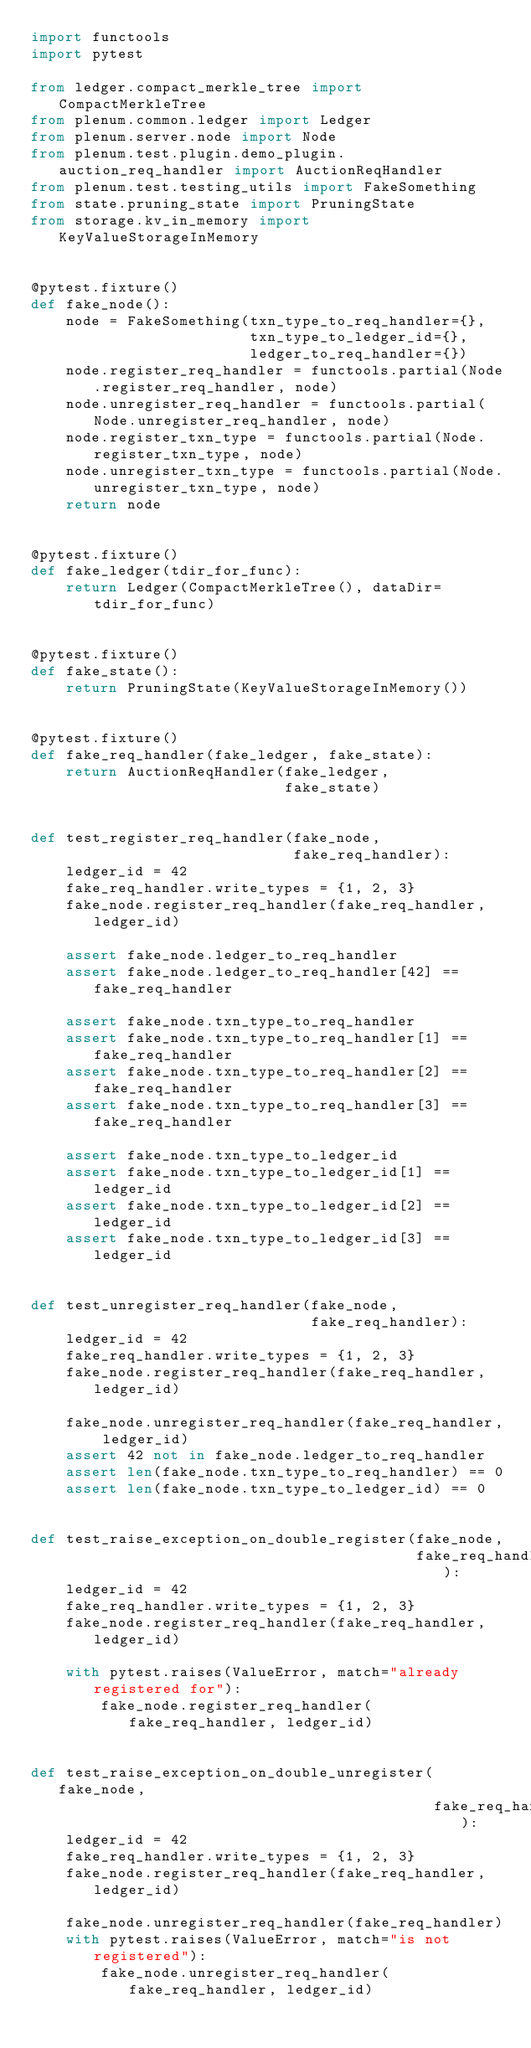Convert code to text. <code><loc_0><loc_0><loc_500><loc_500><_Python_>import functools
import pytest

from ledger.compact_merkle_tree import CompactMerkleTree
from plenum.common.ledger import Ledger
from plenum.server.node import Node
from plenum.test.plugin.demo_plugin.auction_req_handler import AuctionReqHandler
from plenum.test.testing_utils import FakeSomething
from state.pruning_state import PruningState
from storage.kv_in_memory import KeyValueStorageInMemory


@pytest.fixture()
def fake_node():
    node = FakeSomething(txn_type_to_req_handler={},
                         txn_type_to_ledger_id={},
                         ledger_to_req_handler={})
    node.register_req_handler = functools.partial(Node.register_req_handler, node)
    node.unregister_req_handler = functools.partial(Node.unregister_req_handler, node)
    node.register_txn_type = functools.partial(Node.register_txn_type, node)
    node.unregister_txn_type = functools.partial(Node.unregister_txn_type, node)
    return node


@pytest.fixture()
def fake_ledger(tdir_for_func):
    return Ledger(CompactMerkleTree(), dataDir=tdir_for_func)


@pytest.fixture()
def fake_state():
    return PruningState(KeyValueStorageInMemory())


@pytest.fixture()
def fake_req_handler(fake_ledger, fake_state):
    return AuctionReqHandler(fake_ledger,
                             fake_state)


def test_register_req_handler(fake_node,
                              fake_req_handler):
    ledger_id = 42
    fake_req_handler.write_types = {1, 2, 3}
    fake_node.register_req_handler(fake_req_handler, ledger_id)

    assert fake_node.ledger_to_req_handler
    assert fake_node.ledger_to_req_handler[42] == fake_req_handler

    assert fake_node.txn_type_to_req_handler
    assert fake_node.txn_type_to_req_handler[1] == fake_req_handler
    assert fake_node.txn_type_to_req_handler[2] == fake_req_handler
    assert fake_node.txn_type_to_req_handler[3] == fake_req_handler

    assert fake_node.txn_type_to_ledger_id
    assert fake_node.txn_type_to_ledger_id[1] == ledger_id
    assert fake_node.txn_type_to_ledger_id[2] == ledger_id
    assert fake_node.txn_type_to_ledger_id[3] == ledger_id


def test_unregister_req_handler(fake_node,
                                fake_req_handler):
    ledger_id = 42
    fake_req_handler.write_types = {1, 2, 3}
    fake_node.register_req_handler(fake_req_handler, ledger_id)

    fake_node.unregister_req_handler(fake_req_handler, ledger_id)
    assert 42 not in fake_node.ledger_to_req_handler
    assert len(fake_node.txn_type_to_req_handler) == 0
    assert len(fake_node.txn_type_to_ledger_id) == 0


def test_raise_exception_on_double_register(fake_node,
                                            fake_req_handler):
    ledger_id = 42
    fake_req_handler.write_types = {1, 2, 3}
    fake_node.register_req_handler(fake_req_handler, ledger_id)

    with pytest.raises(ValueError, match="already registered for"):
        fake_node.register_req_handler(fake_req_handler, ledger_id)


def test_raise_exception_on_double_unregister(fake_node,
                                              fake_req_handler):
    ledger_id = 42
    fake_req_handler.write_types = {1, 2, 3}
    fake_node.register_req_handler(fake_req_handler, ledger_id)

    fake_node.unregister_req_handler(fake_req_handler)
    with pytest.raises(ValueError, match="is not registered"):
        fake_node.unregister_req_handler(fake_req_handler, ledger_id)
</code> 